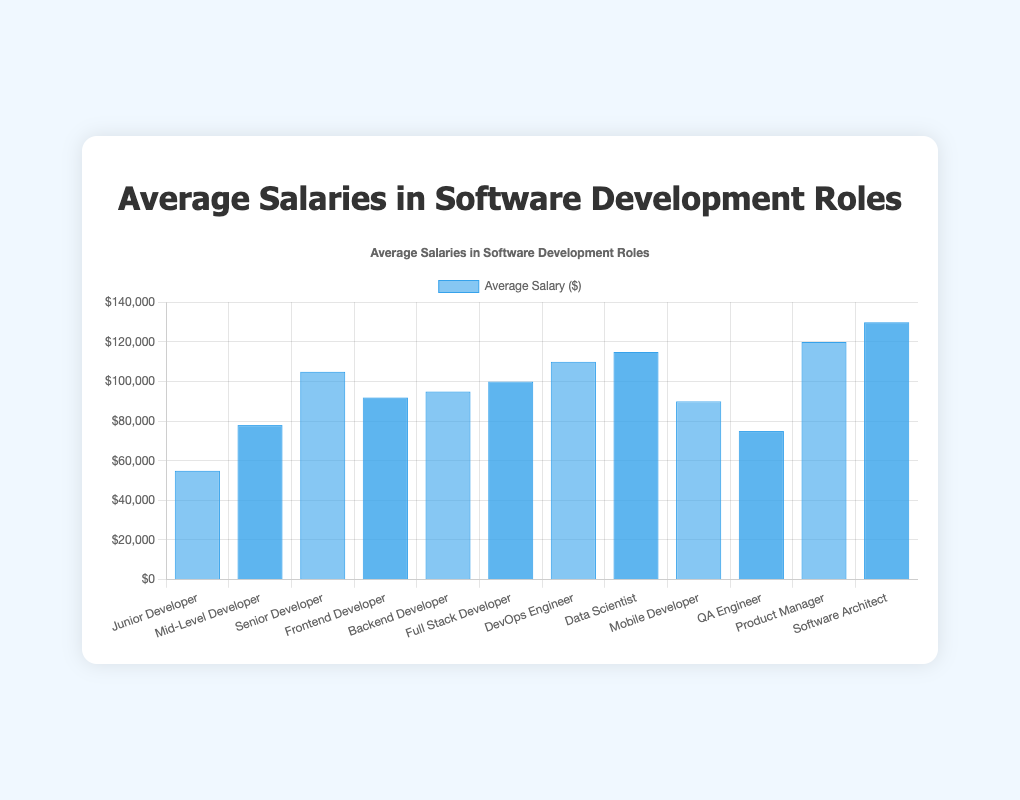Which role has the highest average salary? The highest bar in the chart indicates the highest salary, which corresponds to the "Software Architect" role with an average salary of $130,000.
Answer: Software Architect How much more does a Senior Developer earn compared to a Junior Developer? The bar heights for the "Senior Developer" and "Junior Developer" roles show $105,000 and $55,000, respectively. The difference is $105,000 - $55,000 = $50,000.
Answer: $50,000 What is the average salary of a Full Stack Developer compared to a Backend Developer? The chart indicates that a Full Stack Developer earns $100,000 and a Backend Developer earns $95,000. Therefore, the Full Stack Developer earns $100,000 - $95,000 = $5,000 more.
Answer: $5,000 Which roles have average salaries under $80,000? Bars corresponding to "Junior Developer" at $55,000 and "QA Engineer" at $75,000 are under the $80,000 mark on the chart.
Answer: Junior Developer, QA Engineer What is the sum of average salaries for Mid-Level Developer, Mobile Developer, and QA Engineer? Adding the average salaries indicated by the bars: $78,000 (Mid-Level Developer) + $90,000 (Mobile Developer) + $75,000 (QA Engineer) results in $243,000.
Answer: $243,000 What is the highest paid role among Frontend Developer, Backend Developer, and Full Stack Developer? The bars for these roles show average salaries of $92,000 (Frontend Developer), $95,000 (Backend Developer), and $100,000 (Full Stack Developer). The highest is Full Stack Developer.
Answer: Full Stack Developer How does the average salary of a Data Scientist compare to that of a Product Manager? The bars indicate that a Data Scientist earns $115,000 while a Product Manager earns $120,000.
Answer: Data Scientist earns $5,000 less What is the combined average salary of a DevOps Engineer and a Senior Developer? Adding the average salaries given in the chart: $110,000 (DevOps Engineer) + $105,000 (Senior Developer) results in $215,000.
Answer: $215,000 Which role earns the lowest salary, and how much is it? The shortest bar in the chart corresponds to the "Junior Developer" role with an average salary of $55,000.
Answer: Junior Developer, $55,000 What is the average salary difference between a Mobile Developer and a Frontend Developer? The average salaries are $90,000 (Mobile Developer) and $92,000 (Frontend Developer), respectively. The difference is $92,000 - $90,000 = $2,000.
Answer: $2,000 